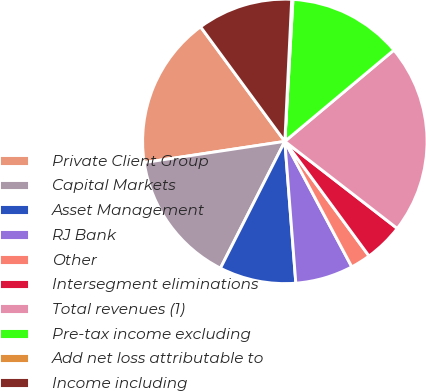<chart> <loc_0><loc_0><loc_500><loc_500><pie_chart><fcel>Private Client Group<fcel>Capital Markets<fcel>Asset Management<fcel>RJ Bank<fcel>Other<fcel>Intersegment eliminations<fcel>Total revenues (1)<fcel>Pre-tax income excluding<fcel>Add net loss attributable to<fcel>Income including<nl><fcel>17.29%<fcel>15.14%<fcel>8.71%<fcel>6.57%<fcel>2.28%<fcel>4.43%<fcel>21.58%<fcel>13.0%<fcel>0.14%<fcel>10.86%<nl></chart> 